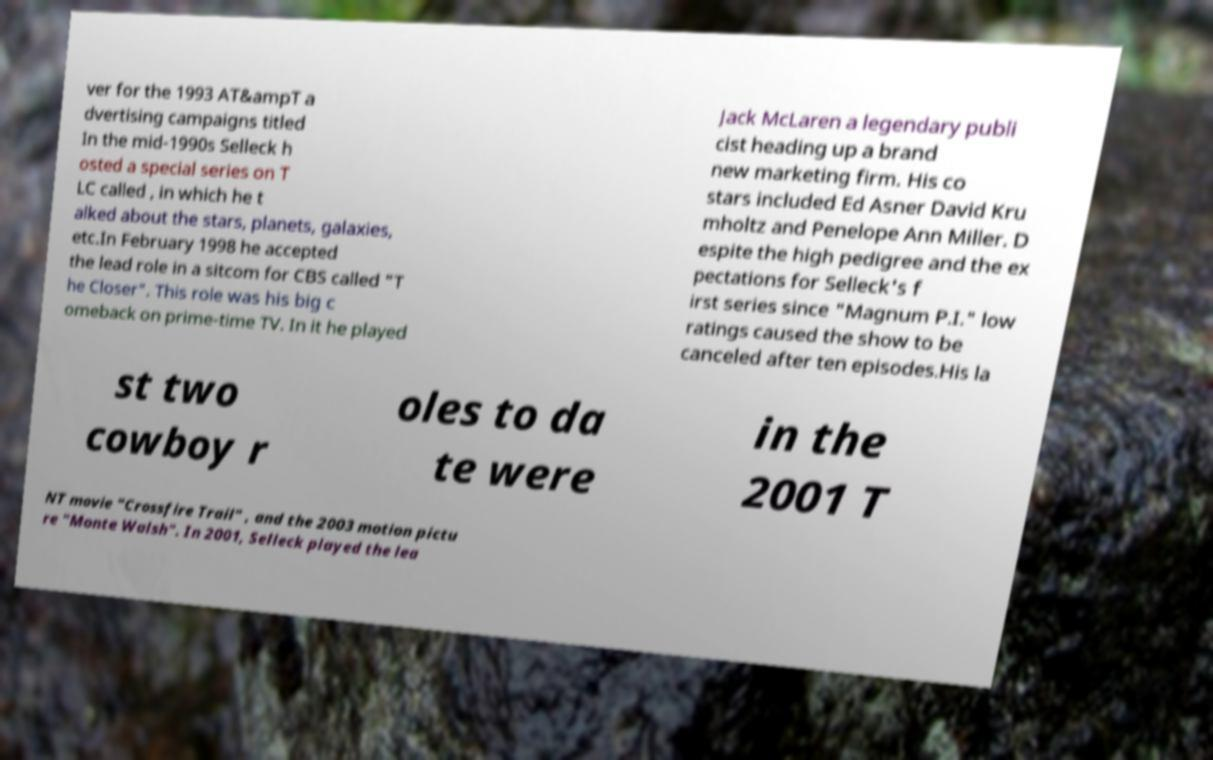Can you read and provide the text displayed in the image?This photo seems to have some interesting text. Can you extract and type it out for me? ver for the 1993 AT&ampT a dvertising campaigns titled In the mid-1990s Selleck h osted a special series on T LC called , in which he t alked about the stars, planets, galaxies, etc.In February 1998 he accepted the lead role in a sitcom for CBS called "T he Closer". This role was his big c omeback on prime-time TV. In it he played Jack McLaren a legendary publi cist heading up a brand new marketing firm. His co stars included Ed Asner David Kru mholtz and Penelope Ann Miller. D espite the high pedigree and the ex pectations for Selleck's f irst series since "Magnum P.I." low ratings caused the show to be canceled after ten episodes.His la st two cowboy r oles to da te were in the 2001 T NT movie "Crossfire Trail" , and the 2003 motion pictu re "Monte Walsh". In 2001, Selleck played the lea 